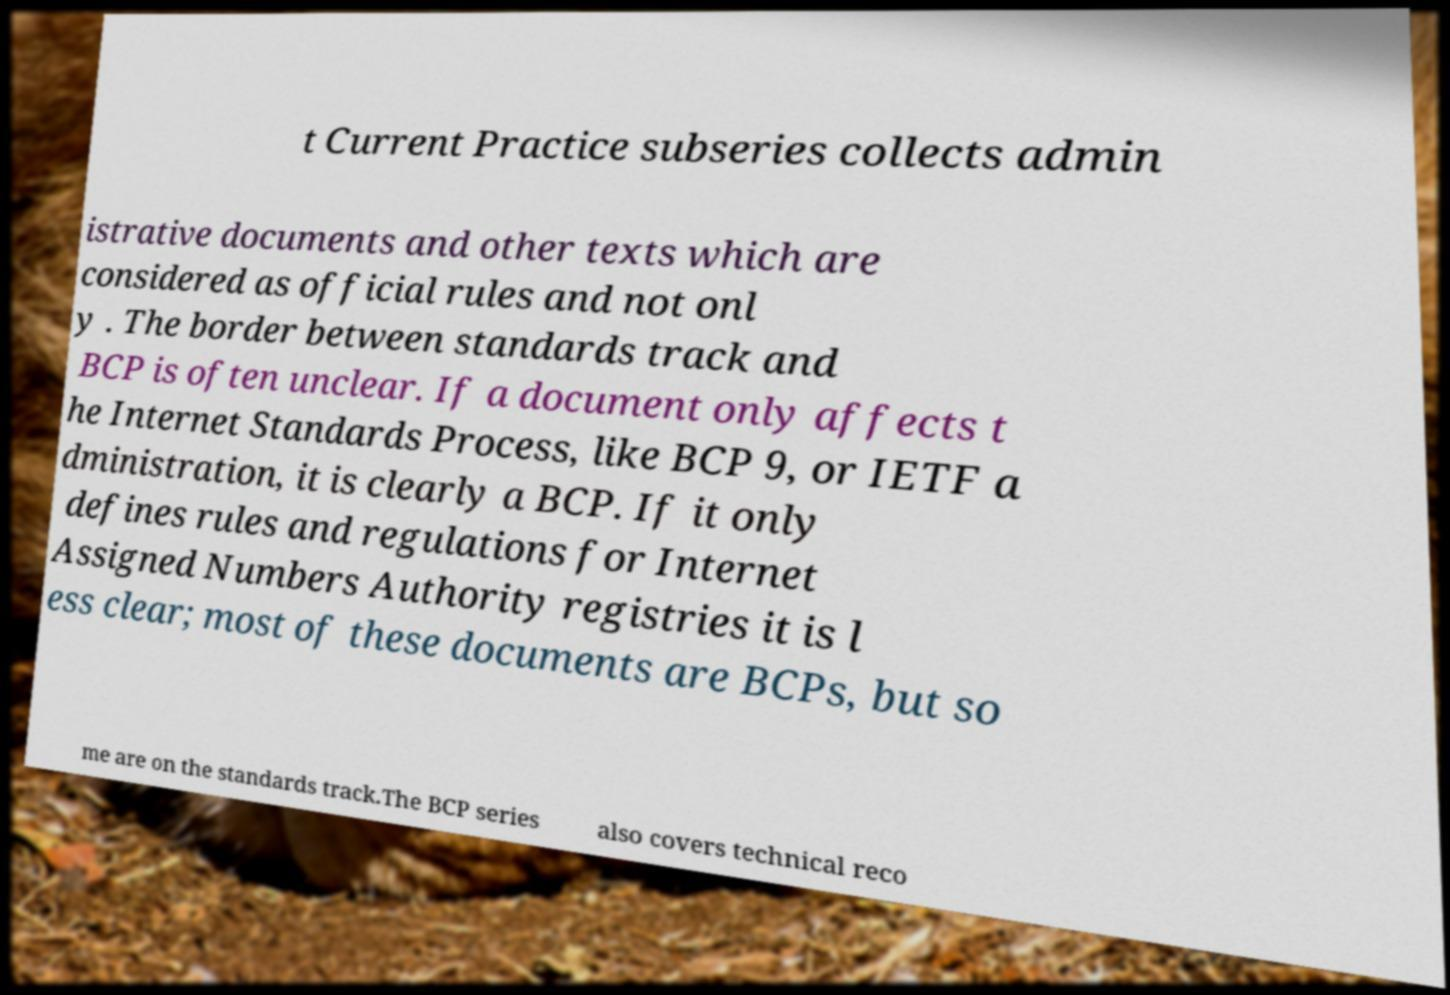I need the written content from this picture converted into text. Can you do that? t Current Practice subseries collects admin istrative documents and other texts which are considered as official rules and not onl y . The border between standards track and BCP is often unclear. If a document only affects t he Internet Standards Process, like BCP 9, or IETF a dministration, it is clearly a BCP. If it only defines rules and regulations for Internet Assigned Numbers Authority registries it is l ess clear; most of these documents are BCPs, but so me are on the standards track.The BCP series also covers technical reco 